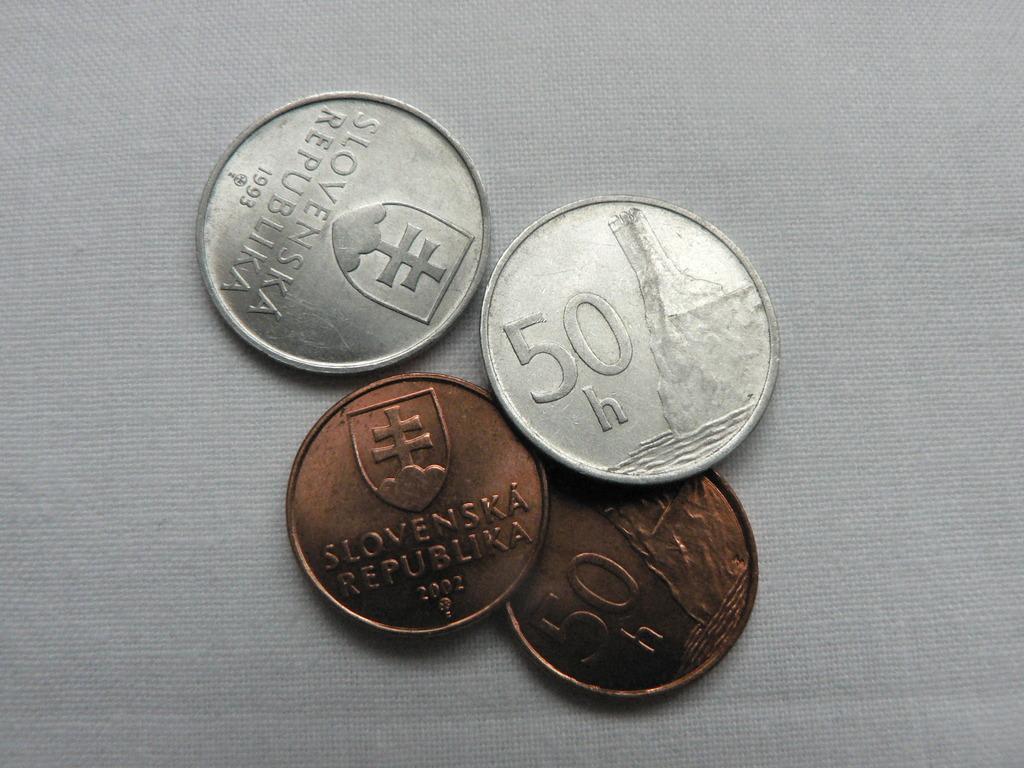Could you give a brief overview of what you see in this image? In this image I can see four coins visible on white color cloth. 